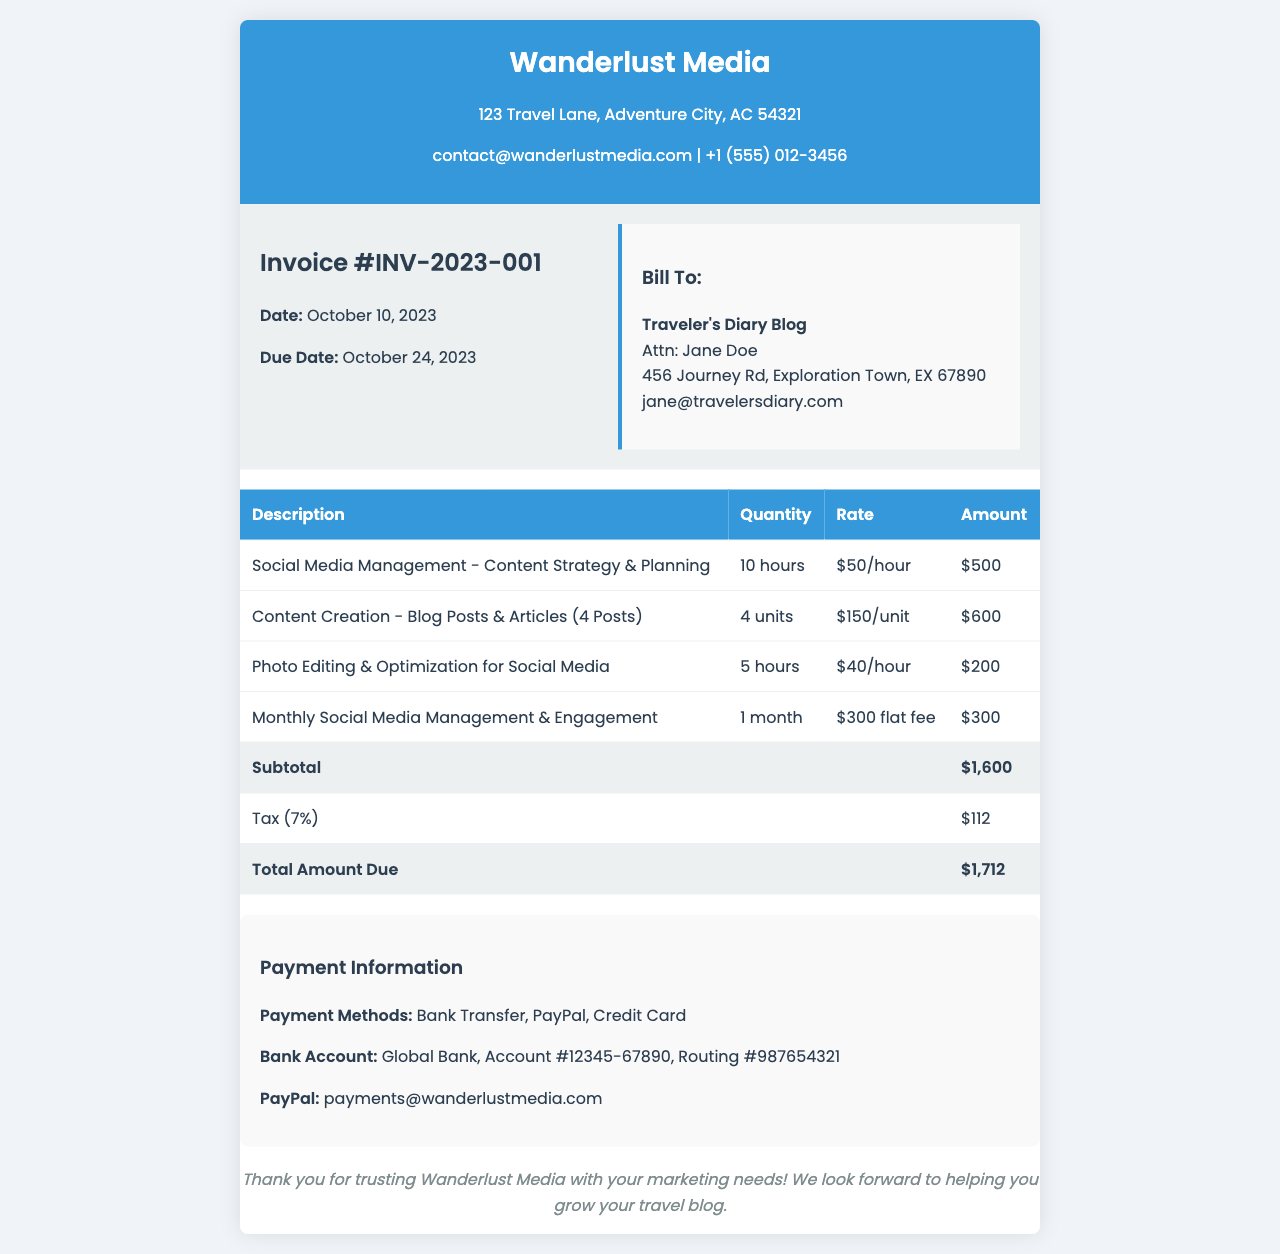What is the invoice number? The invoice number is stated in the document as "INV-2023-001."
Answer: INV-2023-001 What is the date of the invoice? The date of the invoice is mentioned as "October 10, 2023."
Answer: October 10, 2023 What is the total amount due? The total amount due is displayed as "$1,712."
Answer: $1,712 How many blog posts are included in the content creation fee? The content creation fee includes "4 Posts."
Answer: 4 Posts What is the tax percentage applied to the subtotal? The tax percentage applied is "7%."
Answer: 7% Who is the client for this invoice? The client's name is provided as "Traveler's Diary Blog."
Answer: Traveler's Diary Blog What is the rate for photo editing per hour? The rate for photo editing is "$40/hour."
Answer: $40/hour What payment methods are accepted? The accepted payment methods are "Bank Transfer, PayPal, Credit Card."
Answer: Bank Transfer, PayPal, Credit Card What is the subtotal amount before tax? The subtotal amount before tax is indicated as "$1,600."
Answer: $1,600 